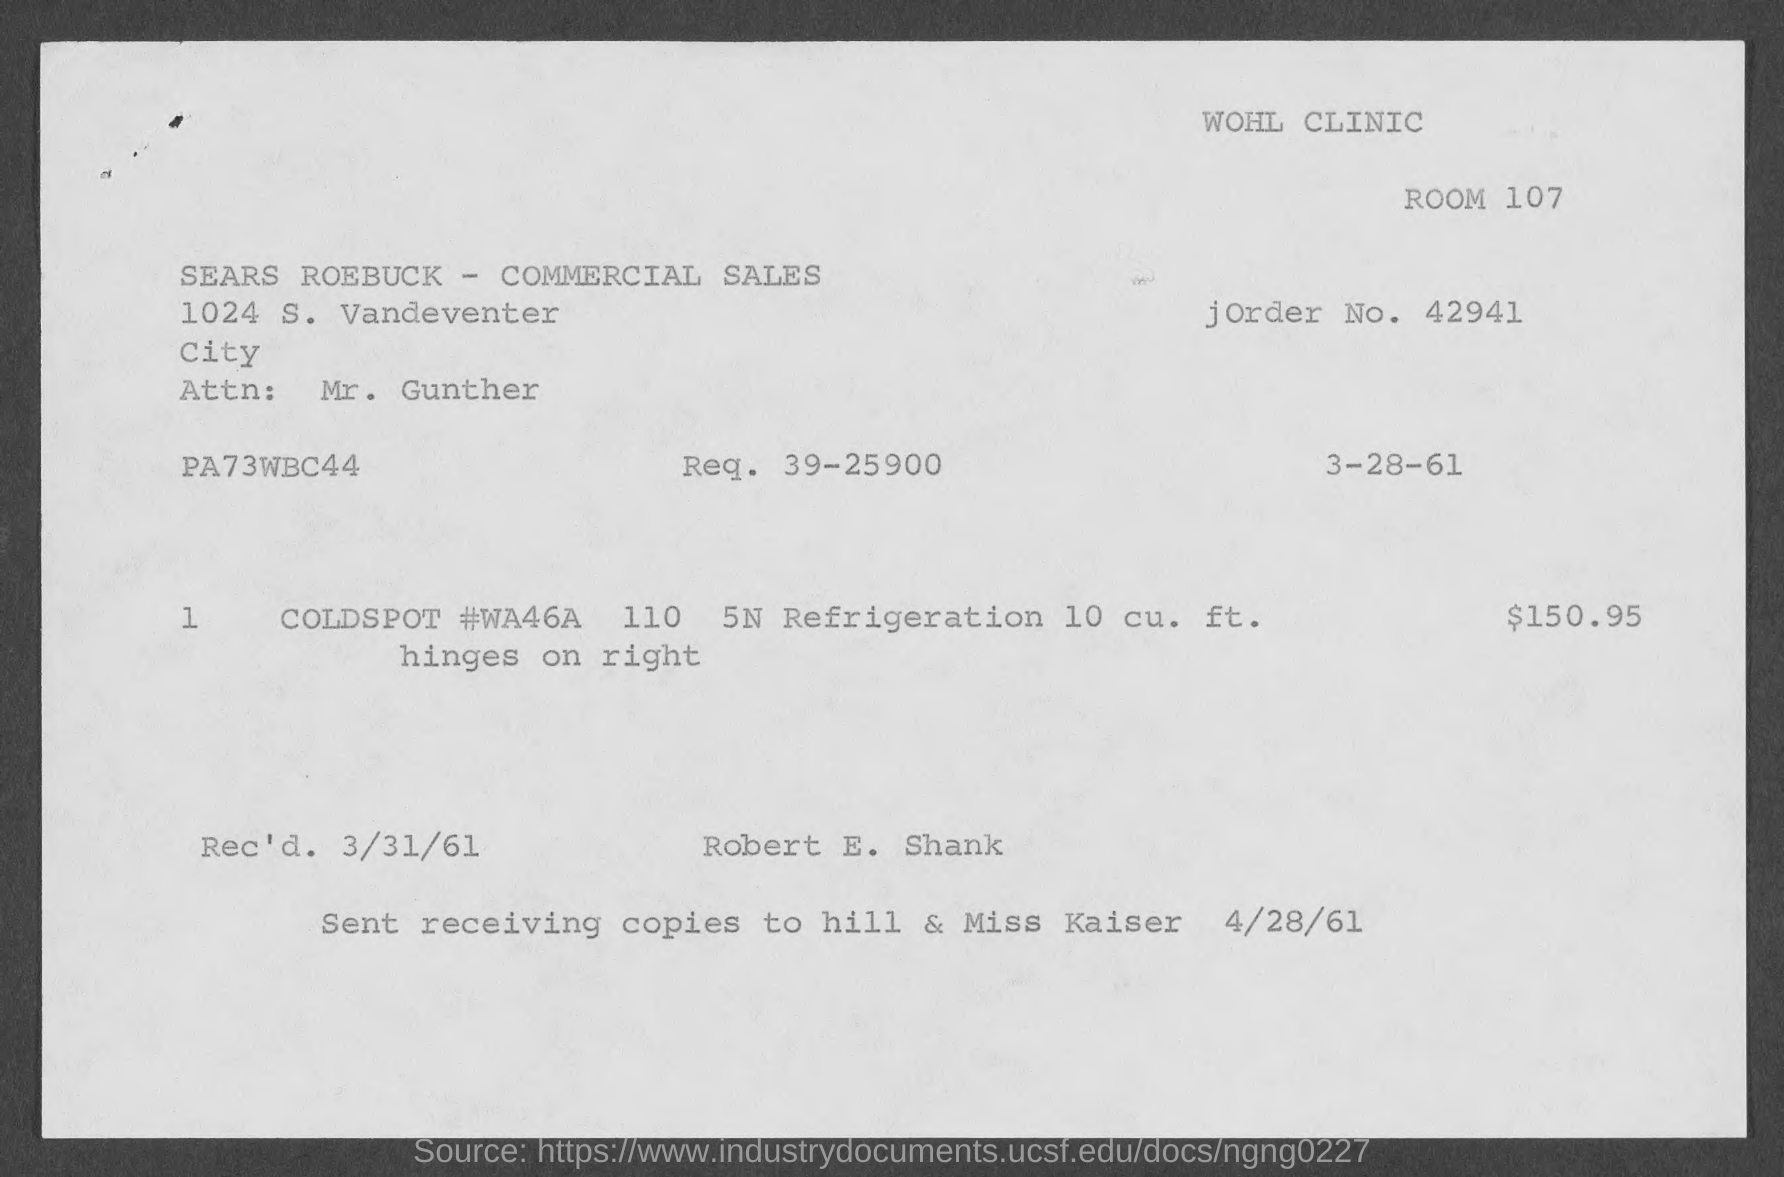Highlight a few significant elements in this photo. The amount mentioned in the given form is $150.95. The room number mentioned in the given page is 107. Please specify the requested value in the given form. The acceptable range is 39 to 25900. The J order number mentioned in the given page is 42941. The received date mentioned in the given page is March 31, 1961. 